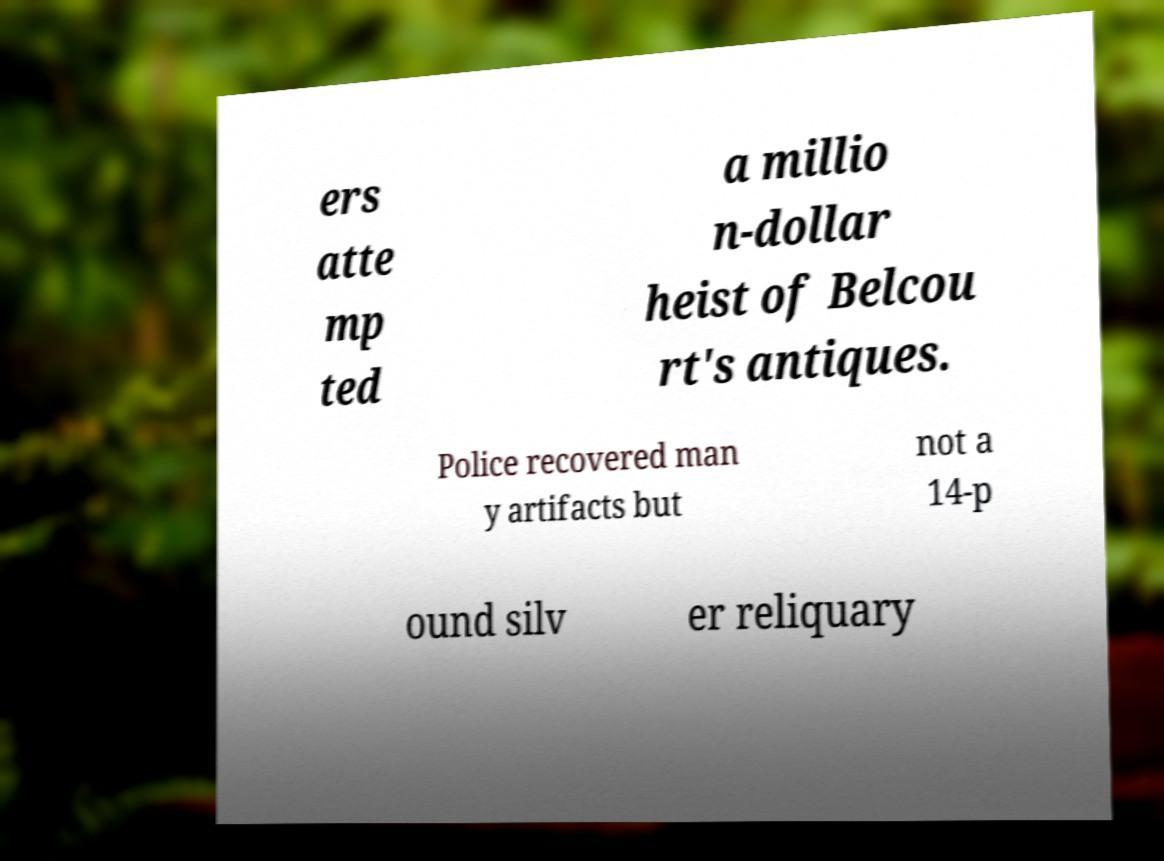What messages or text are displayed in this image? I need them in a readable, typed format. ers atte mp ted a millio n-dollar heist of Belcou rt's antiques. Police recovered man y artifacts but not a 14-p ound silv er reliquary 